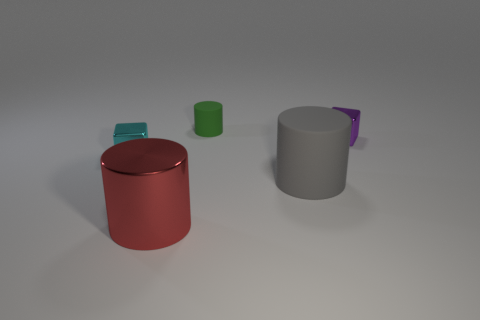What size is the green object that is the same shape as the red shiny object?
Keep it short and to the point. Small. Is the shape of the big thing right of the green object the same as  the small purple shiny object?
Provide a succinct answer. No. What color is the block to the right of the tiny matte thing?
Give a very brief answer. Purple. What number of other objects are the same size as the cyan block?
Provide a succinct answer. 2. Is there any other thing that has the same shape as the small cyan object?
Provide a short and direct response. Yes. Are there an equal number of cyan blocks that are to the right of the green matte cylinder and small blue spheres?
Your answer should be very brief. Yes. How many tiny gray things have the same material as the large gray cylinder?
Give a very brief answer. 0. What color is the cylinder that is the same material as the gray thing?
Provide a short and direct response. Green. Is the shape of the small rubber object the same as the purple object?
Your answer should be very brief. No. Is there a small cube that is to the left of the rubber cylinder that is behind the small purple thing that is on the right side of the gray rubber thing?
Your response must be concise. Yes. 